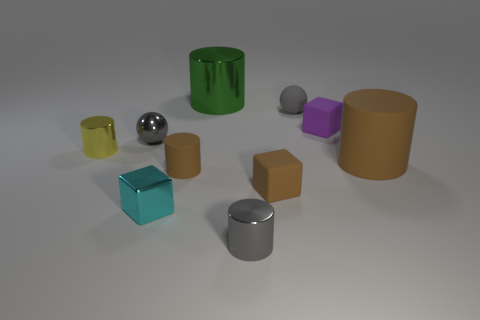Is the number of green cylinders that are behind the large green metallic object greater than the number of yellow metallic objects right of the small cyan thing?
Provide a succinct answer. No. There is a tiny sphere to the right of the small gray shiny sphere; what material is it?
Give a very brief answer. Rubber. There is a small yellow object; is it the same shape as the object that is behind the gray matte thing?
Provide a short and direct response. Yes. How many gray matte objects are on the right side of the tiny matte cube behind the small gray metal ball that is in front of the purple block?
Your answer should be compact. 0. There is a tiny metal thing that is the same shape as the tiny purple rubber thing; what is its color?
Give a very brief answer. Cyan. Are there any other things that have the same shape as the small purple thing?
Keep it short and to the point. Yes. What number of cylinders are either tiny gray rubber things or tiny cyan matte things?
Make the answer very short. 0. The green thing is what shape?
Offer a very short reply. Cylinder. There is a small brown cylinder; are there any cyan shiny objects behind it?
Your response must be concise. No. Is the small brown cylinder made of the same material as the purple block in front of the big green metal cylinder?
Offer a very short reply. Yes. 